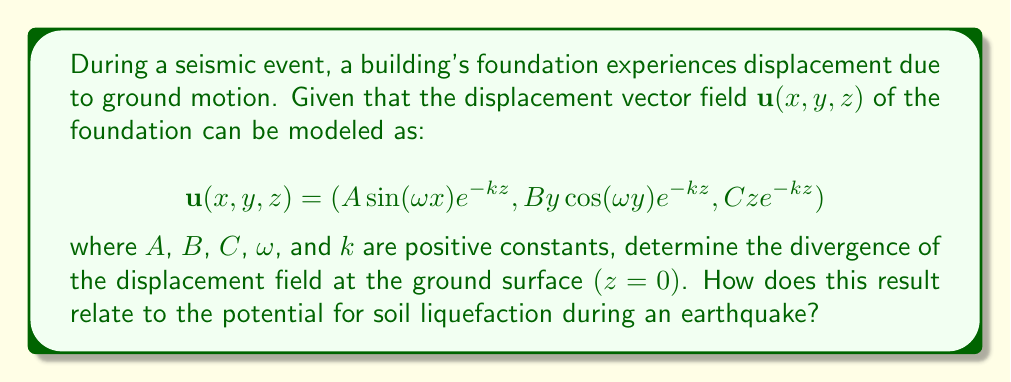Can you solve this math problem? To solve this problem, we'll follow these steps:

1) The divergence of a vector field $\mathbf{u}(x,y,z) = (u_x, u_y, u_z)$ is given by:

   $$\nabla \cdot \mathbf{u} = \frac{\partial u_x}{\partial x} + \frac{\partial u_y}{\partial y} + \frac{\partial u_z}{\partial z}$$

2) Let's calculate each partial derivative:

   $$\frac{\partial u_x}{\partial x} = A\omega \cos(\omega x)e^{-kz}$$
   
   $$\frac{\partial u_y}{\partial y} = B\cos(\omega y)e^{-kz} - By\omega\sin(\omega y)e^{-kz}$$
   
   $$\frac{\partial u_z}{\partial z} = Ce^{-kz} - Ckze^{-kz}$$

3) Now, we sum these partial derivatives:

   $$\nabla \cdot \mathbf{u} = A\omega \cos(\omega x)e^{-kz} + B\cos(\omega y)e^{-kz} - By\omega\sin(\omega y)e^{-kz} + Ce^{-kz} - Ckze^{-kz}$$

4) We're asked to evaluate this at the ground surface where $z=0$. Substituting $z=0$:

   $$\nabla \cdot \mathbf{u}|_{z=0} = A\omega \cos(\omega x) + B\cos(\omega y) - By\omega\sin(\omega y) + C$$

5) This result shows that the divergence at the ground surface varies with $x$ and $y$, indicating that different parts of the foundation may experience different degrees of volume change during the earthquake.

6) Relating to soil liquefaction:
   - Positive divergence indicates expansion, which can lead to decreased soil density and increased pore water pressure.
   - Negative divergence indicates compression, which can increase pore water pressure if the soil is saturated.
   - Both scenarios can contribute to soil liquefaction, especially in sandy or silty soils.
   - The periodic nature of the divergence (due to sine and cosine terms) suggests that liquefaction potential may vary across the foundation area.
Answer: $\nabla \cdot \mathbf{u}|_{z=0} = A\omega \cos(\omega x) + B\cos(\omega y) - By\omega\sin(\omega y) + C$ 